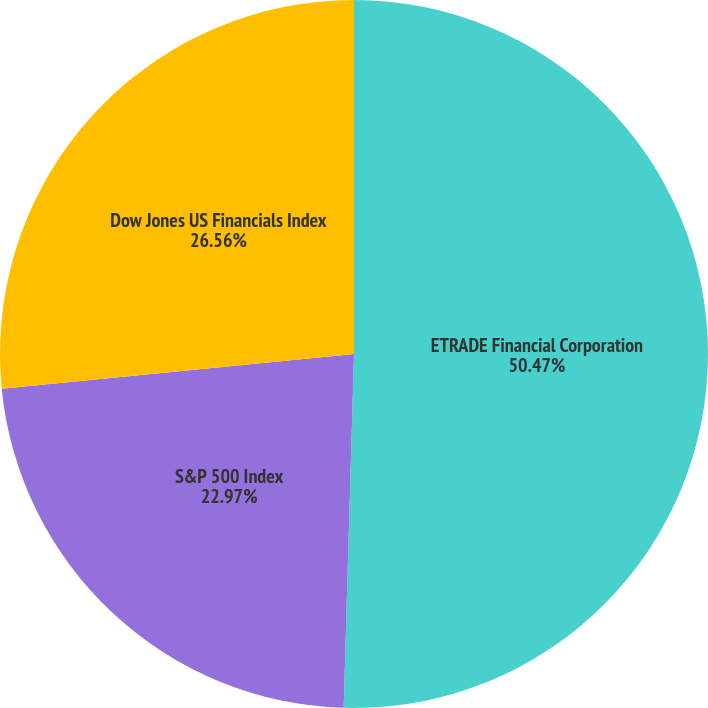<chart> <loc_0><loc_0><loc_500><loc_500><pie_chart><fcel>ETRADE Financial Corporation<fcel>S&P 500 Index<fcel>Dow Jones US Financials Index<nl><fcel>50.46%<fcel>22.97%<fcel>26.56%<nl></chart> 